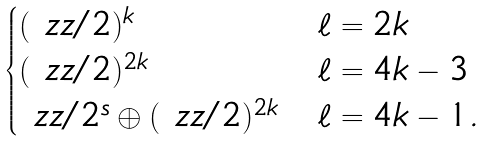Convert formula to latex. <formula><loc_0><loc_0><loc_500><loc_500>\begin{cases} ( \ z z / 2 ) ^ { k } & \ell = 2 k \\ ( \ z z / 2 ) ^ { 2 k } & \ell = 4 k - 3 \\ \ z z / 2 ^ { s } \oplus ( \ z z / 2 ) ^ { 2 k } & \ell = 4 k - 1 . \end{cases}</formula> 